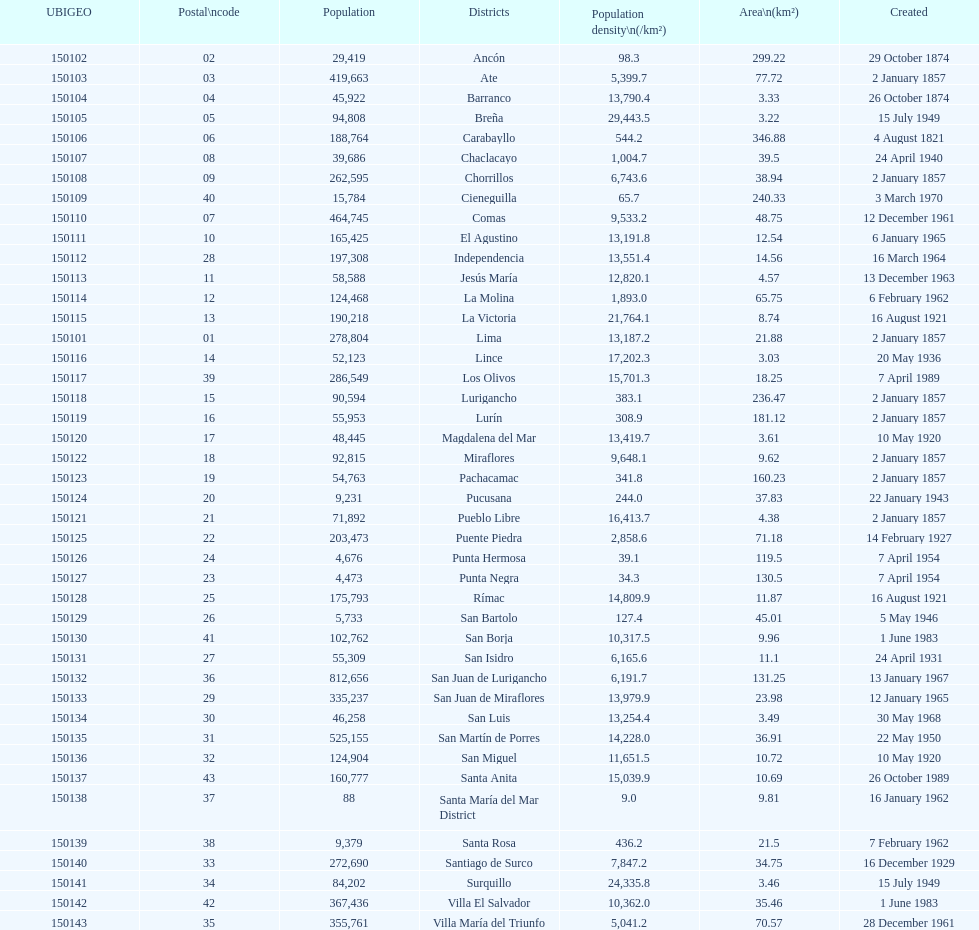Which is the largest district in terms of population? San Juan de Lurigancho. 